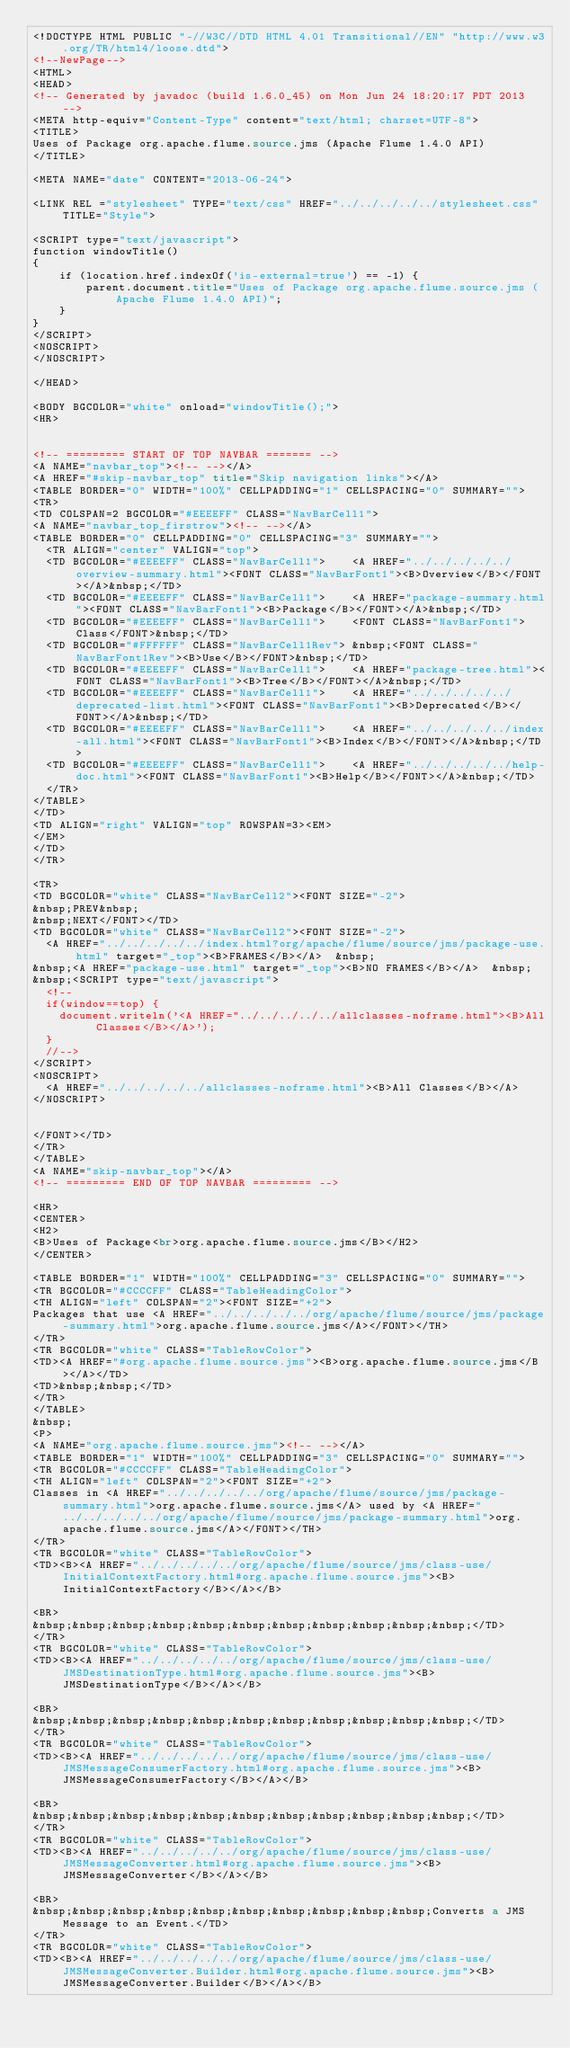Convert code to text. <code><loc_0><loc_0><loc_500><loc_500><_HTML_><!DOCTYPE HTML PUBLIC "-//W3C//DTD HTML 4.01 Transitional//EN" "http://www.w3.org/TR/html4/loose.dtd">
<!--NewPage-->
<HTML>
<HEAD>
<!-- Generated by javadoc (build 1.6.0_45) on Mon Jun 24 18:20:17 PDT 2013 -->
<META http-equiv="Content-Type" content="text/html; charset=UTF-8">
<TITLE>
Uses of Package org.apache.flume.source.jms (Apache Flume 1.4.0 API)
</TITLE>

<META NAME="date" CONTENT="2013-06-24">

<LINK REL ="stylesheet" TYPE="text/css" HREF="../../../../../stylesheet.css" TITLE="Style">

<SCRIPT type="text/javascript">
function windowTitle()
{
    if (location.href.indexOf('is-external=true') == -1) {
        parent.document.title="Uses of Package org.apache.flume.source.jms (Apache Flume 1.4.0 API)";
    }
}
</SCRIPT>
<NOSCRIPT>
</NOSCRIPT>

</HEAD>

<BODY BGCOLOR="white" onload="windowTitle();">
<HR>


<!-- ========= START OF TOP NAVBAR ======= -->
<A NAME="navbar_top"><!-- --></A>
<A HREF="#skip-navbar_top" title="Skip navigation links"></A>
<TABLE BORDER="0" WIDTH="100%" CELLPADDING="1" CELLSPACING="0" SUMMARY="">
<TR>
<TD COLSPAN=2 BGCOLOR="#EEEEFF" CLASS="NavBarCell1">
<A NAME="navbar_top_firstrow"><!-- --></A>
<TABLE BORDER="0" CELLPADDING="0" CELLSPACING="3" SUMMARY="">
  <TR ALIGN="center" VALIGN="top">
  <TD BGCOLOR="#EEEEFF" CLASS="NavBarCell1">    <A HREF="../../../../../overview-summary.html"><FONT CLASS="NavBarFont1"><B>Overview</B></FONT></A>&nbsp;</TD>
  <TD BGCOLOR="#EEEEFF" CLASS="NavBarCell1">    <A HREF="package-summary.html"><FONT CLASS="NavBarFont1"><B>Package</B></FONT></A>&nbsp;</TD>
  <TD BGCOLOR="#EEEEFF" CLASS="NavBarCell1">    <FONT CLASS="NavBarFont1">Class</FONT>&nbsp;</TD>
  <TD BGCOLOR="#FFFFFF" CLASS="NavBarCell1Rev"> &nbsp;<FONT CLASS="NavBarFont1Rev"><B>Use</B></FONT>&nbsp;</TD>
  <TD BGCOLOR="#EEEEFF" CLASS="NavBarCell1">    <A HREF="package-tree.html"><FONT CLASS="NavBarFont1"><B>Tree</B></FONT></A>&nbsp;</TD>
  <TD BGCOLOR="#EEEEFF" CLASS="NavBarCell1">    <A HREF="../../../../../deprecated-list.html"><FONT CLASS="NavBarFont1"><B>Deprecated</B></FONT></A>&nbsp;</TD>
  <TD BGCOLOR="#EEEEFF" CLASS="NavBarCell1">    <A HREF="../../../../../index-all.html"><FONT CLASS="NavBarFont1"><B>Index</B></FONT></A>&nbsp;</TD>
  <TD BGCOLOR="#EEEEFF" CLASS="NavBarCell1">    <A HREF="../../../../../help-doc.html"><FONT CLASS="NavBarFont1"><B>Help</B></FONT></A>&nbsp;</TD>
  </TR>
</TABLE>
</TD>
<TD ALIGN="right" VALIGN="top" ROWSPAN=3><EM>
</EM>
</TD>
</TR>

<TR>
<TD BGCOLOR="white" CLASS="NavBarCell2"><FONT SIZE="-2">
&nbsp;PREV&nbsp;
&nbsp;NEXT</FONT></TD>
<TD BGCOLOR="white" CLASS="NavBarCell2"><FONT SIZE="-2">
  <A HREF="../../../../../index.html?org/apache/flume/source/jms/package-use.html" target="_top"><B>FRAMES</B></A>  &nbsp;
&nbsp;<A HREF="package-use.html" target="_top"><B>NO FRAMES</B></A>  &nbsp;
&nbsp;<SCRIPT type="text/javascript">
  <!--
  if(window==top) {
    document.writeln('<A HREF="../../../../../allclasses-noframe.html"><B>All Classes</B></A>');
  }
  //-->
</SCRIPT>
<NOSCRIPT>
  <A HREF="../../../../../allclasses-noframe.html"><B>All Classes</B></A>
</NOSCRIPT>


</FONT></TD>
</TR>
</TABLE>
<A NAME="skip-navbar_top"></A>
<!-- ========= END OF TOP NAVBAR ========= -->

<HR>
<CENTER>
<H2>
<B>Uses of Package<br>org.apache.flume.source.jms</B></H2>
</CENTER>

<TABLE BORDER="1" WIDTH="100%" CELLPADDING="3" CELLSPACING="0" SUMMARY="">
<TR BGCOLOR="#CCCCFF" CLASS="TableHeadingColor">
<TH ALIGN="left" COLSPAN="2"><FONT SIZE="+2">
Packages that use <A HREF="../../../../../org/apache/flume/source/jms/package-summary.html">org.apache.flume.source.jms</A></FONT></TH>
</TR>
<TR BGCOLOR="white" CLASS="TableRowColor">
<TD><A HREF="#org.apache.flume.source.jms"><B>org.apache.flume.source.jms</B></A></TD>
<TD>&nbsp;&nbsp;</TD>
</TR>
</TABLE>
&nbsp;
<P>
<A NAME="org.apache.flume.source.jms"><!-- --></A>
<TABLE BORDER="1" WIDTH="100%" CELLPADDING="3" CELLSPACING="0" SUMMARY="">
<TR BGCOLOR="#CCCCFF" CLASS="TableHeadingColor">
<TH ALIGN="left" COLSPAN="2"><FONT SIZE="+2">
Classes in <A HREF="../../../../../org/apache/flume/source/jms/package-summary.html">org.apache.flume.source.jms</A> used by <A HREF="../../../../../org/apache/flume/source/jms/package-summary.html">org.apache.flume.source.jms</A></FONT></TH>
</TR>
<TR BGCOLOR="white" CLASS="TableRowColor">
<TD><B><A HREF="../../../../../org/apache/flume/source/jms/class-use/InitialContextFactory.html#org.apache.flume.source.jms"><B>InitialContextFactory</B></A></B>

<BR>
&nbsp;&nbsp;&nbsp;&nbsp;&nbsp;&nbsp;&nbsp;&nbsp;&nbsp;&nbsp;&nbsp;</TD>
</TR>
<TR BGCOLOR="white" CLASS="TableRowColor">
<TD><B><A HREF="../../../../../org/apache/flume/source/jms/class-use/JMSDestinationType.html#org.apache.flume.source.jms"><B>JMSDestinationType</B></A></B>

<BR>
&nbsp;&nbsp;&nbsp;&nbsp;&nbsp;&nbsp;&nbsp;&nbsp;&nbsp;&nbsp;&nbsp;</TD>
</TR>
<TR BGCOLOR="white" CLASS="TableRowColor">
<TD><B><A HREF="../../../../../org/apache/flume/source/jms/class-use/JMSMessageConsumerFactory.html#org.apache.flume.source.jms"><B>JMSMessageConsumerFactory</B></A></B>

<BR>
&nbsp;&nbsp;&nbsp;&nbsp;&nbsp;&nbsp;&nbsp;&nbsp;&nbsp;&nbsp;&nbsp;</TD>
</TR>
<TR BGCOLOR="white" CLASS="TableRowColor">
<TD><B><A HREF="../../../../../org/apache/flume/source/jms/class-use/JMSMessageConverter.html#org.apache.flume.source.jms"><B>JMSMessageConverter</B></A></B>

<BR>
&nbsp;&nbsp;&nbsp;&nbsp;&nbsp;&nbsp;&nbsp;&nbsp;&nbsp;&nbsp;Converts a JMS Message to an Event.</TD>
</TR>
<TR BGCOLOR="white" CLASS="TableRowColor">
<TD><B><A HREF="../../../../../org/apache/flume/source/jms/class-use/JMSMessageConverter.Builder.html#org.apache.flume.source.jms"><B>JMSMessageConverter.Builder</B></A></B>
</code> 